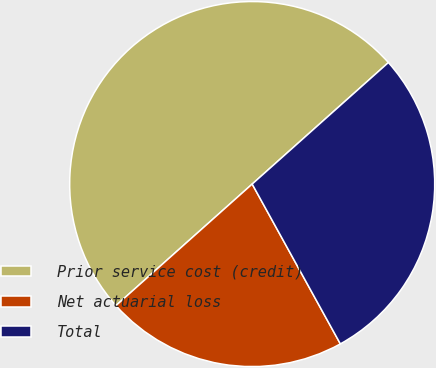<chart> <loc_0><loc_0><loc_500><loc_500><pie_chart><fcel>Prior service cost (credit)<fcel>Net actuarial loss<fcel>Total<nl><fcel>50.0%<fcel>21.43%<fcel>28.57%<nl></chart> 